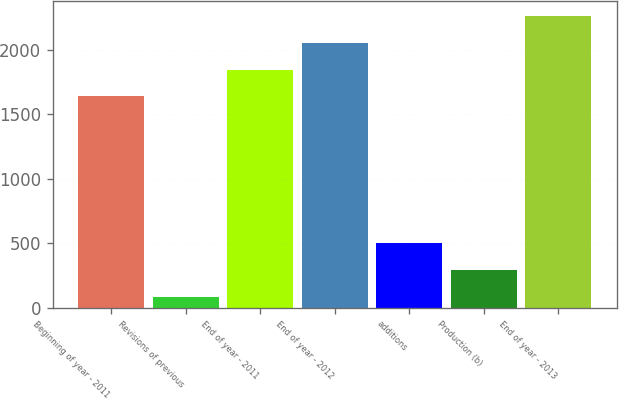Convert chart to OTSL. <chart><loc_0><loc_0><loc_500><loc_500><bar_chart><fcel>Beginning of year - 2011<fcel>Revisions of previous<fcel>End of year - 2011<fcel>End of year - 2012<fcel>additions<fcel>Production (b)<fcel>End of year - 2013<nl><fcel>1638<fcel>87<fcel>1846.4<fcel>2054.8<fcel>503.8<fcel>295.4<fcel>2263.2<nl></chart> 